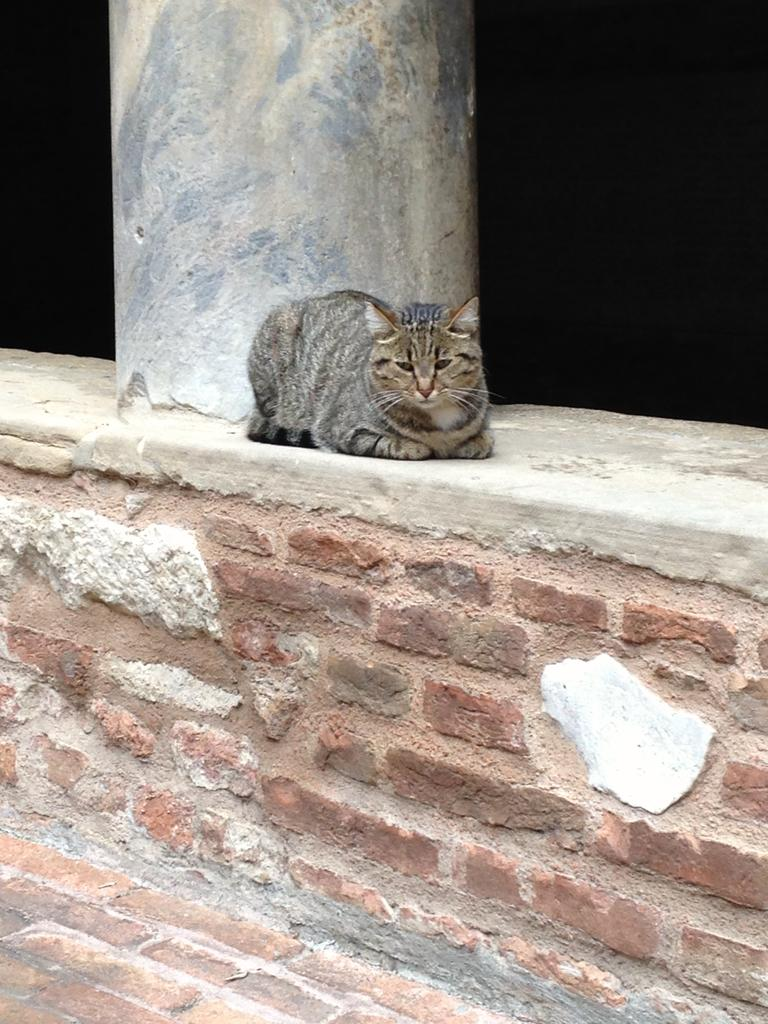What type of animal is in the image? There is a cat in the image. What is the cat doing in the image? The cat is lying on a wall. What type of stem can be seen growing from the cat's back in the image? There is no stem growing from the cat's back in the image. What type of texture can be felt on the cat's fur in the image? The image is a visual representation, so it is not possible to feel the texture of the cat's fur. 